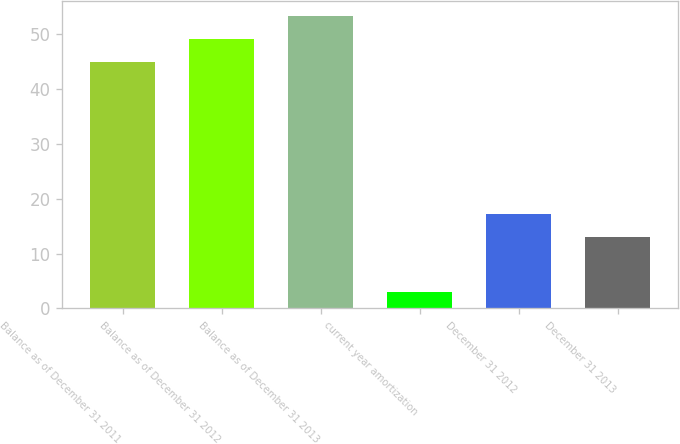Convert chart. <chart><loc_0><loc_0><loc_500><loc_500><bar_chart><fcel>Balance as of December 31 2011<fcel>Balance as of December 31 2012<fcel>Balance as of December 31 2013<fcel>current year amortization<fcel>December 31 2012<fcel>December 31 2013<nl><fcel>45<fcel>49.2<fcel>53.4<fcel>3<fcel>17.2<fcel>13<nl></chart> 